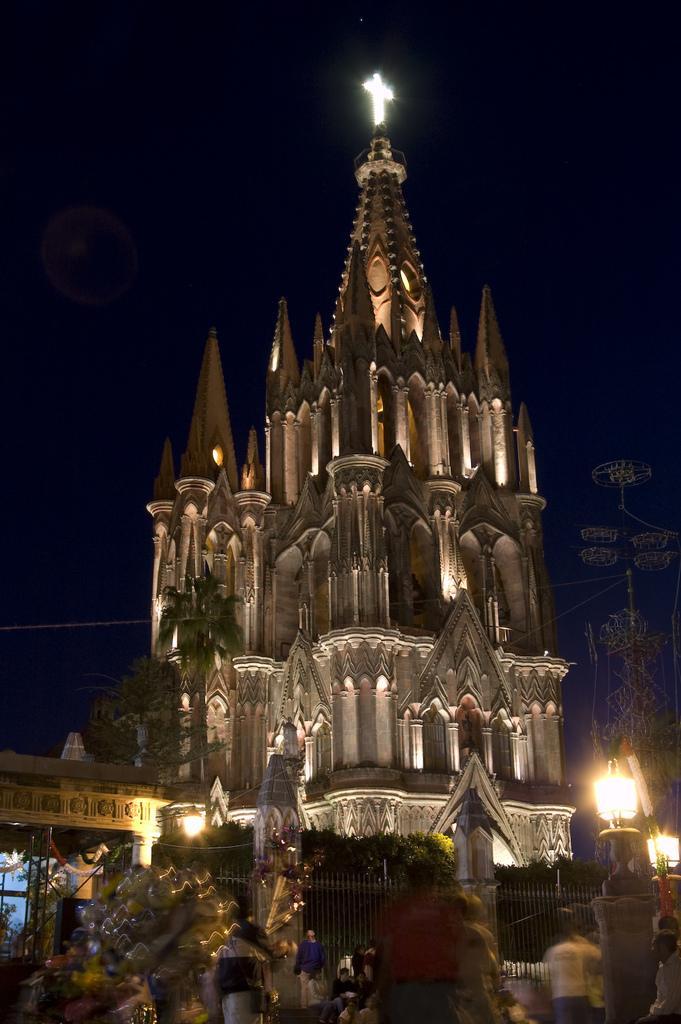Describe this image in one or two sentences. In the center of the image there is a tower and we can see trees. On the right there is a pole and we can see lights. At the bottom there are people. 